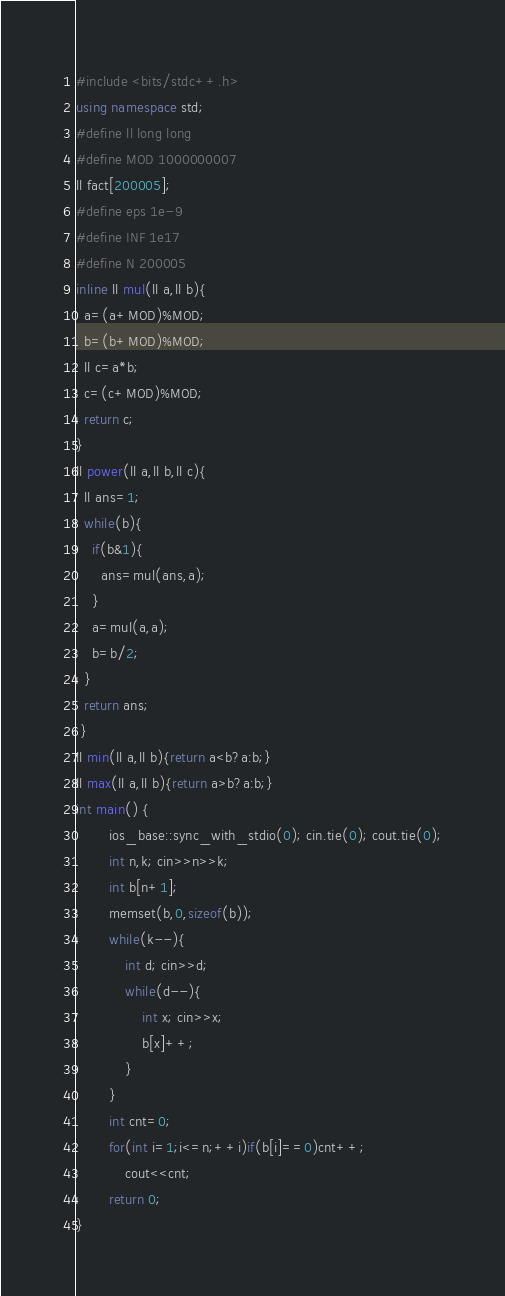<code> <loc_0><loc_0><loc_500><loc_500><_C++_>#include <bits/stdc++.h>
using namespace std;
#define ll long long 
#define MOD 1000000007
ll fact[200005];
#define eps 1e-9
#define INF 1e17
#define N 200005
inline ll mul(ll a,ll b){
  a=(a+MOD)%MOD;
  b=(b+MOD)%MOD;
  ll c=a*b;
  c=(c+MOD)%MOD;
  return c;
}
ll power(ll a,ll b,ll c){
  ll ans=1;
  while(b){
    if(b&1){
      ans=mul(ans,a);
    }
    a=mul(a,a);
    b=b/2;
  }
  return ans;
 }
ll min(ll a,ll b){return a<b?a:b;}
ll max(ll a,ll b){return a>b?a:b;}
int main() {
        ios_base::sync_with_stdio(0); cin.tie(0); cout.tie(0);
        int n,k; cin>>n>>k;
        int b[n+1];
        memset(b,0,sizeof(b));
        while(k--){
            int d; cin>>d;
            while(d--){
                int x; cin>>x;
                b[x]++;
            }
        }
        int cnt=0;
        for(int i=1;i<=n;++i)if(b[i]==0)cnt++;
            cout<<cnt;
        return 0;
}
</code> 